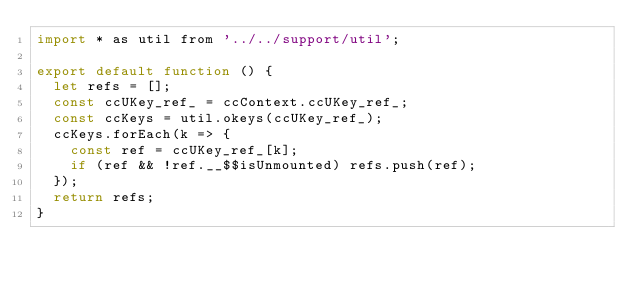Convert code to text. <code><loc_0><loc_0><loc_500><loc_500><_JavaScript_>import * as util from '../../support/util';

export default function () {
  let refs = [];
  const ccUKey_ref_ = ccContext.ccUKey_ref_;
  const ccKeys = util.okeys(ccUKey_ref_);
  ccKeys.forEach(k => {
    const ref = ccUKey_ref_[k];
    if (ref && !ref.__$$isUnmounted) refs.push(ref);
  });
  return refs;
}
</code> 